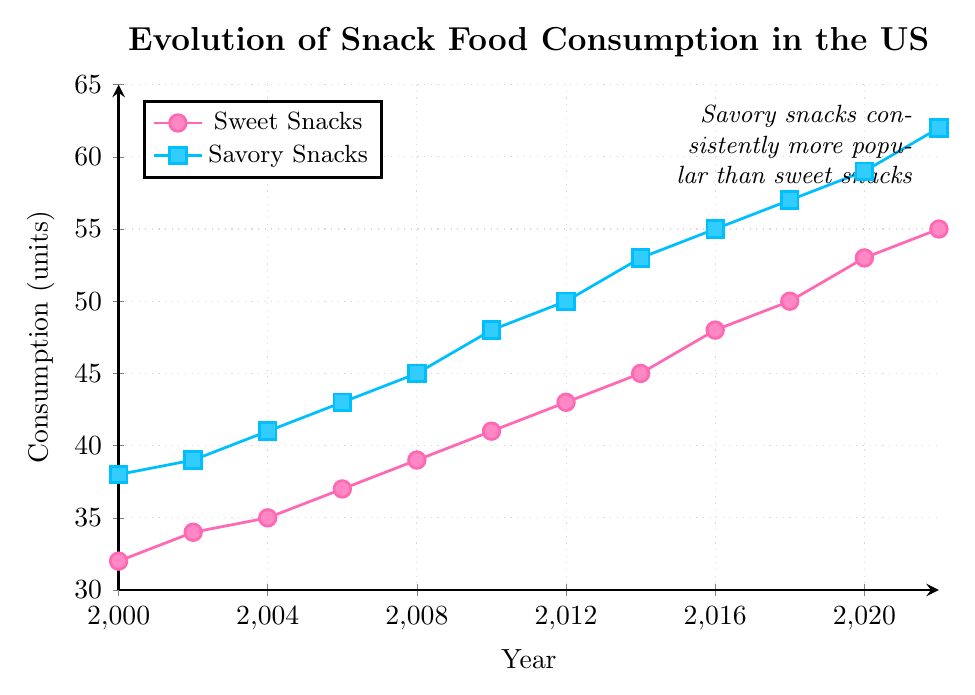What year did sweet snacks consumption reach 50 units? Locate the point on the sweet snacks trend line where the y-axis value is 50. This occurs in the year 2018.
Answer: 2018 Between 2000 and 2022, which category showed a greater increase in consumption? Calculate the difference in consumption for both categories between 2000 and 2022. For sweet snacks: 55 - 32 = 23 units. For savory snacks: 62 - 38 = 24 units. Savory snacks showed a greater increase.
Answer: Savory snacks What is the average consumption of savory snacks over the given period? Add the consumption values of savory snacks for all the years and divide by the number of years. (38 + 39 + 41 + 43 + 45 + 48 + 50 + 53 + 55 + 57 + 59 + 62) = 590, and 590/12 = 49.17 units.
Answer: 49.17 In what year did sweet snacks consume 5 units more than savory snacks did in the year 2000? Savory snacks in the year 2000 were 38 units. 38 + 5 = 43 units. Locate the year where sweet snacks consumption was 43 units, which was in 2012.
Answer: 2012 During which year range did sweet snacks consumption increase the most? Compare the y-axis differences for all adjacent years for sweet snacks to find the largest increase. The largest increase occurred between 2016 and 2018, where consumption grew by 50 - 48 = 2 units.
Answer: 2016-2018 Overall, which category consistently had higher consumption values? Compare the lines for sweet snacks and savory snacks. Savory snacks consistently had higher values throughout the years.
Answer: Savory snacks By how many units did sweet snacks consumption increase between 2000 and 2010? Calculate the difference between the sweet snack consumption values for 2000 and 2010. 41 (2010) - 32 (2000) = 9 units.
Answer: 9 Which year showed the smallest increase in consumption for savory snacks compared to the previous year? Identify the years where savory snacks consumption increased the least compared to the previous year. The smallest increase was between 2000 and 2002, with an increase of 1 unit (39 - 38).
Answer: 2000-2002 By what factor did savory snacks consumption increase from 2000 to 2022? Divide the consumption in 2022 by the consumption in 2000 for savory snacks. 62 / 38 ≈ 1.63.
Answer: 1.63 